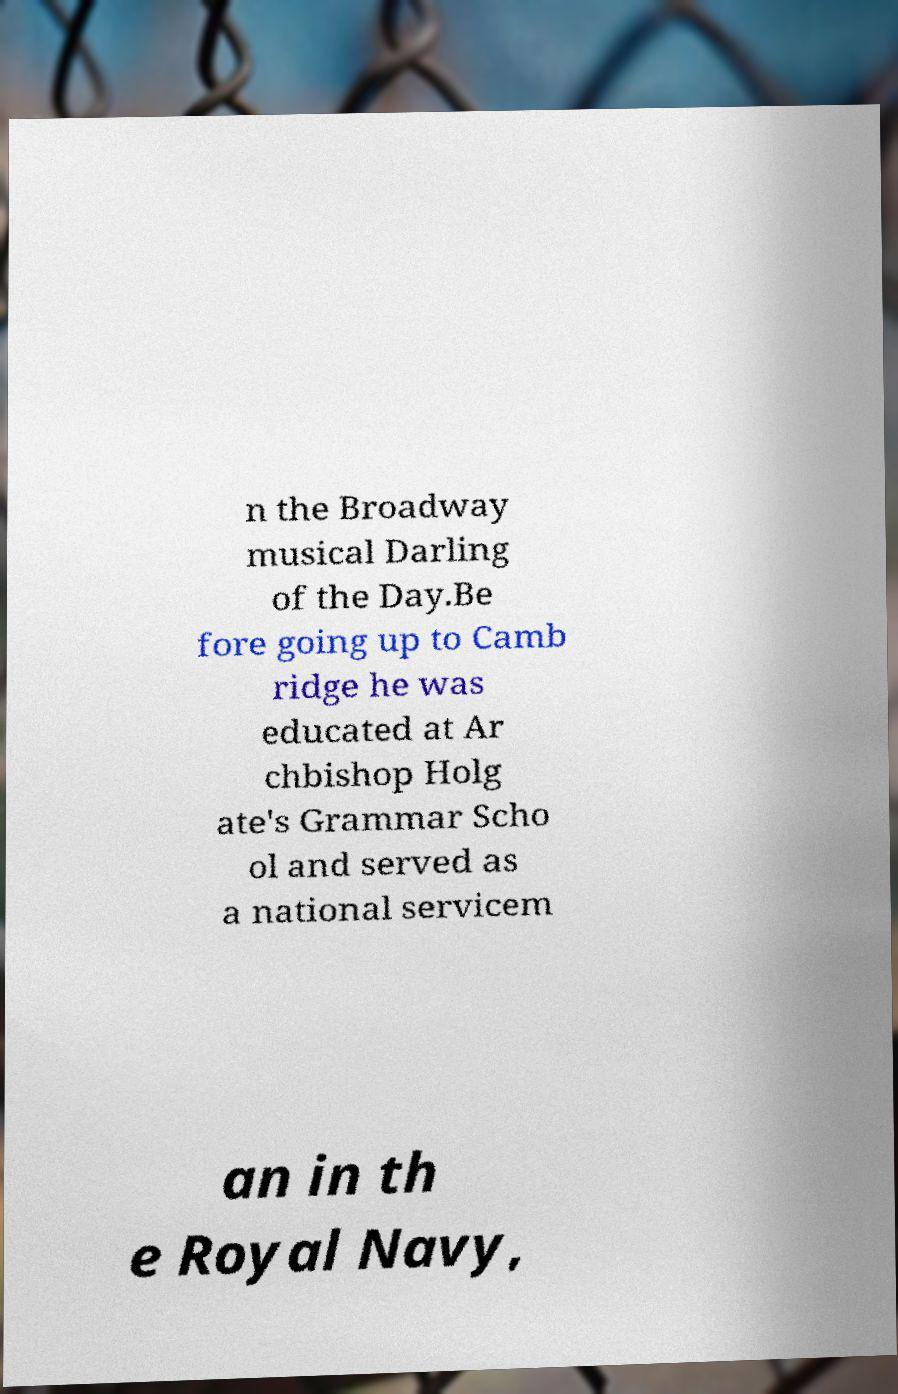What messages or text are displayed in this image? I need them in a readable, typed format. n the Broadway musical Darling of the Day.Be fore going up to Camb ridge he was educated at Ar chbishop Holg ate's Grammar Scho ol and served as a national servicem an in th e Royal Navy, 